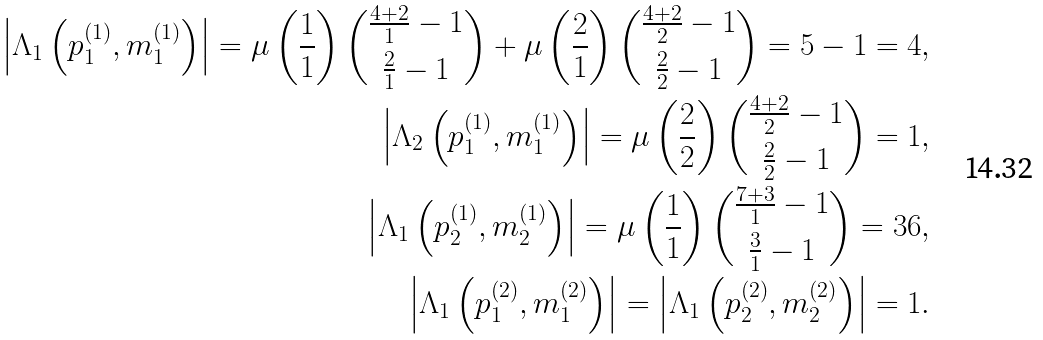Convert formula to latex. <formula><loc_0><loc_0><loc_500><loc_500>\left | \Lambda _ { 1 } \left ( p ^ { ( 1 ) } _ { 1 } , m ^ { ( 1 ) } _ { 1 } \right ) \right | = \mu \left ( \frac { 1 } { 1 } \right ) { \frac { 4 + 2 } { 1 } - 1 \choose \frac { 2 } { 1 } - 1 } + \mu \left ( \frac { 2 } { 1 } \right ) { \frac { 4 + 2 } { 2 } - 1 \choose \frac { 2 } { 2 } - 1 } = 5 - 1 = 4 , \\ \left | \Lambda _ { 2 } \left ( p ^ { ( 1 ) } _ { 1 } , m ^ { ( 1 ) } _ { 1 } \right ) \right | = \mu \left ( \frac { 2 } { 2 } \right ) { \frac { 4 + 2 } { 2 } - 1 \choose \frac { 2 } { 2 } - 1 } = 1 , \\ \left | \Lambda _ { 1 } \left ( p ^ { ( 1 ) } _ { 2 } , m ^ { ( 1 ) } _ { 2 } \right ) \right | = \mu \left ( \frac { 1 } { 1 } \right ) { \frac { 7 + 3 } { 1 } - 1 \choose \frac { 3 } { 1 } - 1 } = 3 6 , \\ \left | \Lambda _ { 1 } \left ( p ^ { ( 2 ) } _ { 1 } , m ^ { ( 2 ) } _ { 1 } \right ) \right | = \left | \Lambda _ { 1 } \left ( p ^ { ( 2 ) } _ { 2 } , m ^ { ( 2 ) } _ { 2 } \right ) \right | = 1 .</formula> 